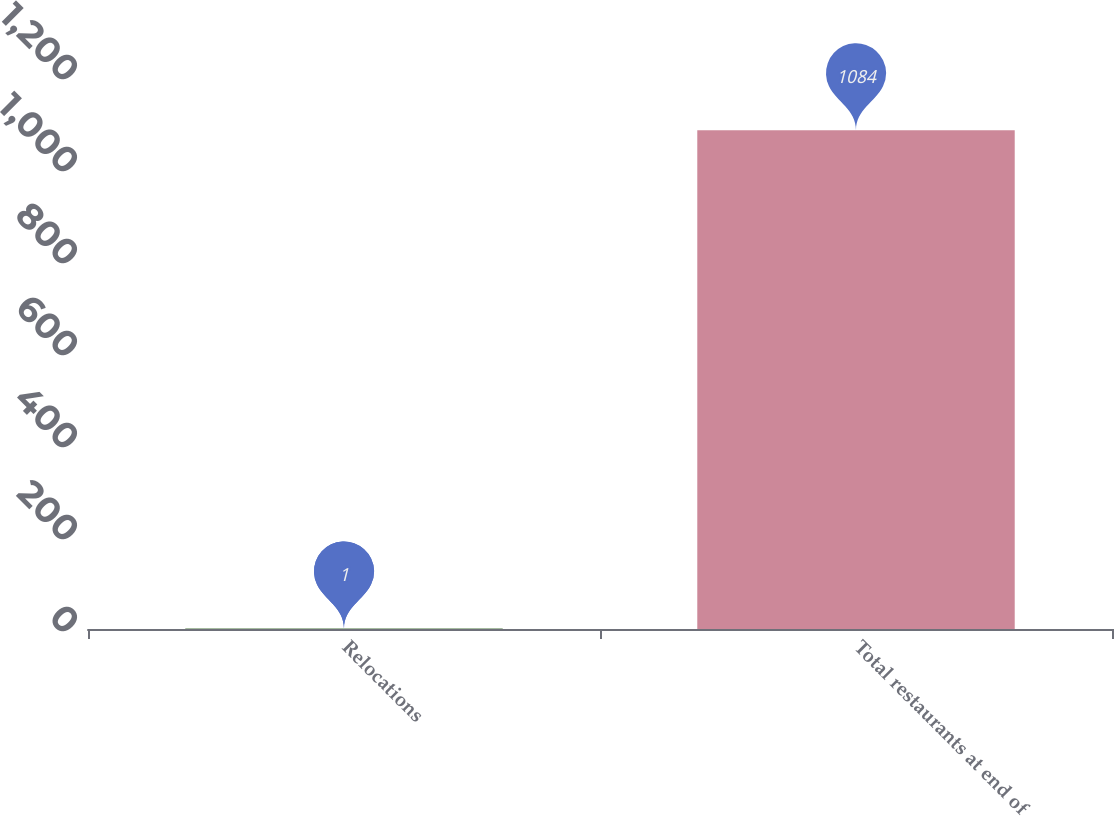<chart> <loc_0><loc_0><loc_500><loc_500><bar_chart><fcel>Relocations<fcel>Total restaurants at end of<nl><fcel>1<fcel>1084<nl></chart> 